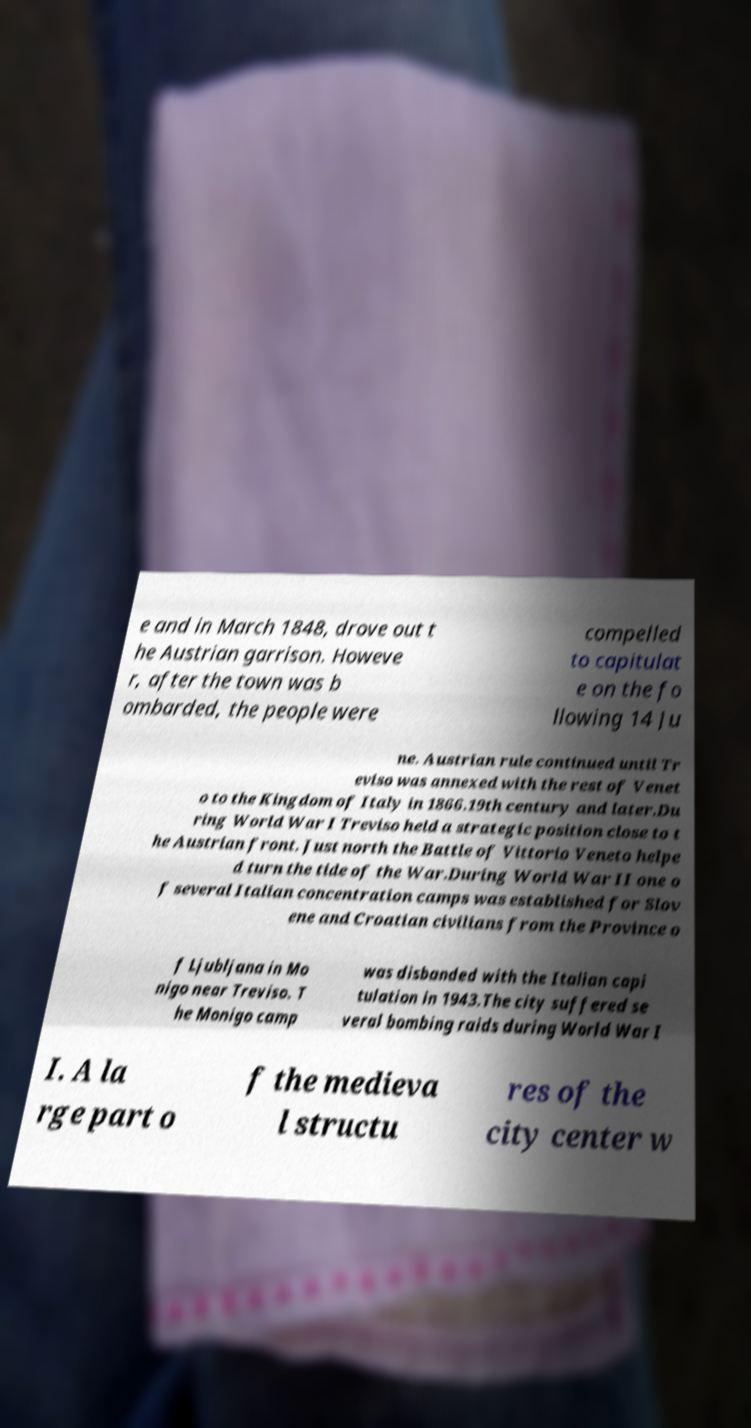Can you accurately transcribe the text from the provided image for me? e and in March 1848, drove out t he Austrian garrison. Howeve r, after the town was b ombarded, the people were compelled to capitulat e on the fo llowing 14 Ju ne. Austrian rule continued until Tr eviso was annexed with the rest of Venet o to the Kingdom of Italy in 1866.19th century and later.Du ring World War I Treviso held a strategic position close to t he Austrian front. Just north the Battle of Vittorio Veneto helpe d turn the tide of the War.During World War II one o f several Italian concentration camps was established for Slov ene and Croatian civilians from the Province o f Ljubljana in Mo nigo near Treviso. T he Monigo camp was disbanded with the Italian capi tulation in 1943.The city suffered se veral bombing raids during World War I I. A la rge part o f the medieva l structu res of the city center w 